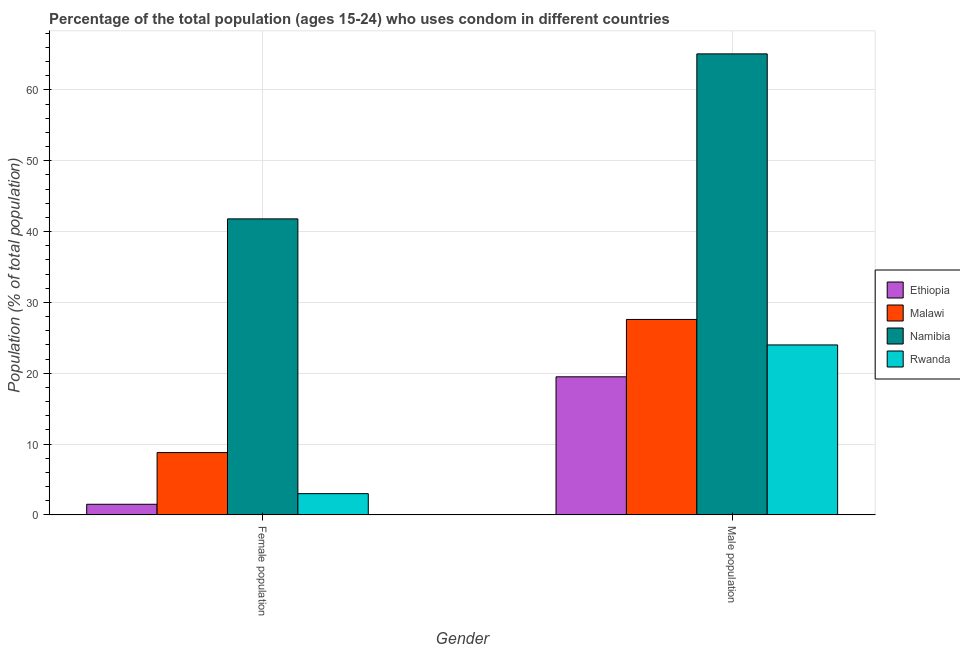How many different coloured bars are there?
Give a very brief answer. 4. Are the number of bars per tick equal to the number of legend labels?
Your answer should be very brief. Yes. How many bars are there on the 2nd tick from the left?
Offer a very short reply. 4. How many bars are there on the 1st tick from the right?
Give a very brief answer. 4. What is the label of the 2nd group of bars from the left?
Your answer should be very brief. Male population. What is the male population in Namibia?
Offer a very short reply. 65.1. Across all countries, what is the maximum male population?
Offer a terse response. 65.1. Across all countries, what is the minimum male population?
Your answer should be very brief. 19.5. In which country was the female population maximum?
Ensure brevity in your answer.  Namibia. In which country was the male population minimum?
Give a very brief answer. Ethiopia. What is the total male population in the graph?
Ensure brevity in your answer.  136.2. What is the difference between the female population in Rwanda and that in Malawi?
Make the answer very short. -5.8. What is the difference between the male population in Namibia and the female population in Malawi?
Offer a terse response. 56.3. What is the average female population per country?
Give a very brief answer. 13.77. In how many countries, is the female population greater than 6 %?
Your answer should be compact. 2. What is the ratio of the male population in Ethiopia to that in Rwanda?
Your answer should be compact. 0.81. What does the 2nd bar from the left in Male population represents?
Offer a terse response. Malawi. What does the 2nd bar from the right in Female population represents?
Offer a terse response. Namibia. How many bars are there?
Provide a short and direct response. 8. How many countries are there in the graph?
Offer a very short reply. 4. What is the difference between two consecutive major ticks on the Y-axis?
Offer a very short reply. 10. Are the values on the major ticks of Y-axis written in scientific E-notation?
Keep it short and to the point. No. Does the graph contain any zero values?
Provide a short and direct response. No. How are the legend labels stacked?
Your response must be concise. Vertical. What is the title of the graph?
Your answer should be compact. Percentage of the total population (ages 15-24) who uses condom in different countries. Does "Vanuatu" appear as one of the legend labels in the graph?
Your answer should be compact. No. What is the label or title of the Y-axis?
Keep it short and to the point. Population (% of total population) . What is the Population (% of total population)  in Ethiopia in Female population?
Offer a terse response. 1.5. What is the Population (% of total population)  in Namibia in Female population?
Your answer should be compact. 41.8. What is the Population (% of total population)  of Malawi in Male population?
Make the answer very short. 27.6. What is the Population (% of total population)  of Namibia in Male population?
Your answer should be compact. 65.1. Across all Gender, what is the maximum Population (% of total population)  of Malawi?
Make the answer very short. 27.6. Across all Gender, what is the maximum Population (% of total population)  of Namibia?
Ensure brevity in your answer.  65.1. Across all Gender, what is the minimum Population (% of total population)  in Malawi?
Offer a terse response. 8.8. Across all Gender, what is the minimum Population (% of total population)  of Namibia?
Provide a short and direct response. 41.8. What is the total Population (% of total population)  in Malawi in the graph?
Offer a terse response. 36.4. What is the total Population (% of total population)  of Namibia in the graph?
Keep it short and to the point. 106.9. What is the total Population (% of total population)  of Rwanda in the graph?
Offer a very short reply. 27. What is the difference between the Population (% of total population)  of Malawi in Female population and that in Male population?
Provide a succinct answer. -18.8. What is the difference between the Population (% of total population)  in Namibia in Female population and that in Male population?
Your answer should be very brief. -23.3. What is the difference between the Population (% of total population)  in Rwanda in Female population and that in Male population?
Keep it short and to the point. -21. What is the difference between the Population (% of total population)  in Ethiopia in Female population and the Population (% of total population)  in Malawi in Male population?
Make the answer very short. -26.1. What is the difference between the Population (% of total population)  of Ethiopia in Female population and the Population (% of total population)  of Namibia in Male population?
Keep it short and to the point. -63.6. What is the difference between the Population (% of total population)  in Ethiopia in Female population and the Population (% of total population)  in Rwanda in Male population?
Your answer should be very brief. -22.5. What is the difference between the Population (% of total population)  in Malawi in Female population and the Population (% of total population)  in Namibia in Male population?
Keep it short and to the point. -56.3. What is the difference between the Population (% of total population)  in Malawi in Female population and the Population (% of total population)  in Rwanda in Male population?
Provide a short and direct response. -15.2. What is the average Population (% of total population)  in Ethiopia per Gender?
Offer a terse response. 10.5. What is the average Population (% of total population)  of Malawi per Gender?
Give a very brief answer. 18.2. What is the average Population (% of total population)  in Namibia per Gender?
Your answer should be very brief. 53.45. What is the average Population (% of total population)  of Rwanda per Gender?
Your answer should be very brief. 13.5. What is the difference between the Population (% of total population)  in Ethiopia and Population (% of total population)  in Namibia in Female population?
Your answer should be very brief. -40.3. What is the difference between the Population (% of total population)  in Ethiopia and Population (% of total population)  in Rwanda in Female population?
Provide a short and direct response. -1.5. What is the difference between the Population (% of total population)  of Malawi and Population (% of total population)  of Namibia in Female population?
Make the answer very short. -33. What is the difference between the Population (% of total population)  in Malawi and Population (% of total population)  in Rwanda in Female population?
Your response must be concise. 5.8. What is the difference between the Population (% of total population)  in Namibia and Population (% of total population)  in Rwanda in Female population?
Provide a short and direct response. 38.8. What is the difference between the Population (% of total population)  in Ethiopia and Population (% of total population)  in Malawi in Male population?
Provide a short and direct response. -8.1. What is the difference between the Population (% of total population)  of Ethiopia and Population (% of total population)  of Namibia in Male population?
Provide a short and direct response. -45.6. What is the difference between the Population (% of total population)  in Ethiopia and Population (% of total population)  in Rwanda in Male population?
Your answer should be compact. -4.5. What is the difference between the Population (% of total population)  in Malawi and Population (% of total population)  in Namibia in Male population?
Provide a succinct answer. -37.5. What is the difference between the Population (% of total population)  in Malawi and Population (% of total population)  in Rwanda in Male population?
Provide a short and direct response. 3.6. What is the difference between the Population (% of total population)  in Namibia and Population (% of total population)  in Rwanda in Male population?
Give a very brief answer. 41.1. What is the ratio of the Population (% of total population)  in Ethiopia in Female population to that in Male population?
Your answer should be very brief. 0.08. What is the ratio of the Population (% of total population)  of Malawi in Female population to that in Male population?
Make the answer very short. 0.32. What is the ratio of the Population (% of total population)  in Namibia in Female population to that in Male population?
Your answer should be very brief. 0.64. What is the ratio of the Population (% of total population)  in Rwanda in Female population to that in Male population?
Keep it short and to the point. 0.12. What is the difference between the highest and the second highest Population (% of total population)  of Ethiopia?
Your answer should be compact. 18. What is the difference between the highest and the second highest Population (% of total population)  of Malawi?
Give a very brief answer. 18.8. What is the difference between the highest and the second highest Population (% of total population)  of Namibia?
Your answer should be compact. 23.3. What is the difference between the highest and the second highest Population (% of total population)  of Rwanda?
Provide a short and direct response. 21. What is the difference between the highest and the lowest Population (% of total population)  in Namibia?
Make the answer very short. 23.3. 